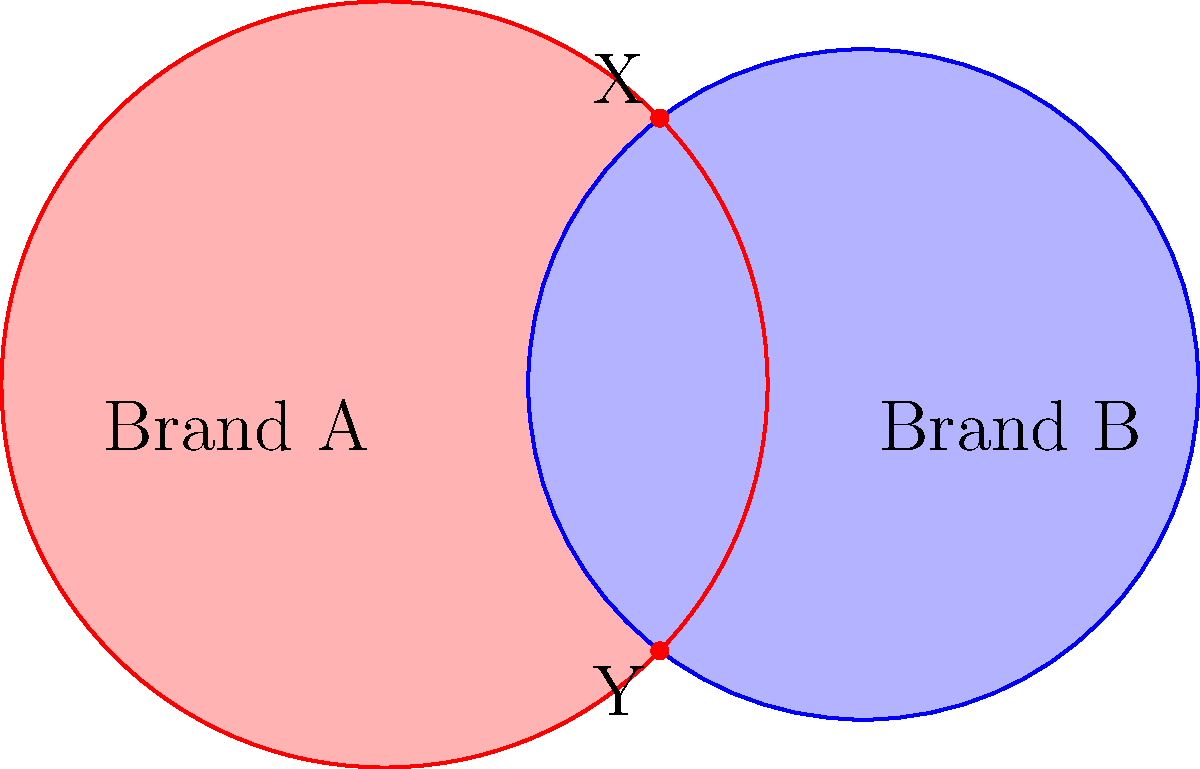As a graphic design student, you're tasked with creating a Venn diagram to compare two brands using overlapping circles. The centers of the circles are 100 units apart. Brand A's circle has a radius of 80 units, while Brand B's circle has a radius of 70 units. What is the length of the line segment XY formed by the intersection points of the two circles? To find the length of XY, we'll use the following steps:

1) First, we need to find the distance between the centers of the circles. We're given that it's 100 units.

2) We'll use the formula for the distance between intersection points of two circles:

   $$d = 2\sqrt{\frac{(r_1^2-r_2^2+D^2)(r_1^2+r_2^2-D^2)}{4D^2}}$$

   Where:
   $d$ is the distance between intersection points
   $r_1$ is the radius of the first circle (80)
   $r_2$ is the radius of the second circle (70)
   $D$ is the distance between circle centers (100)

3) Let's substitute these values:

   $$d = 2\sqrt{\frac{(80^2-70^2+100^2)(80^2+70^2-100^2)}{4(100^2)}}$$

4) Simplify inside the parentheses:

   $$d = 2\sqrt{\frac{(6400-4900+10000)(6400+4900-10000)}{40000}}$$
   $$d = 2\sqrt{\frac{(11500)(1300)}{40000}}$$

5) Multiply the numbers in the numerator:

   $$d = 2\sqrt{\frac{14950000}{40000}}$$

6) Simplify the fraction:

   $$d = 2\sqrt{373.75}$$

7) Calculate the square root:

   $$d = 2(19.33)$$

8) Multiply:

   $$d = 38.66$$

Therefore, the length of XY is approximately 38.66 units.
Answer: 38.66 units 